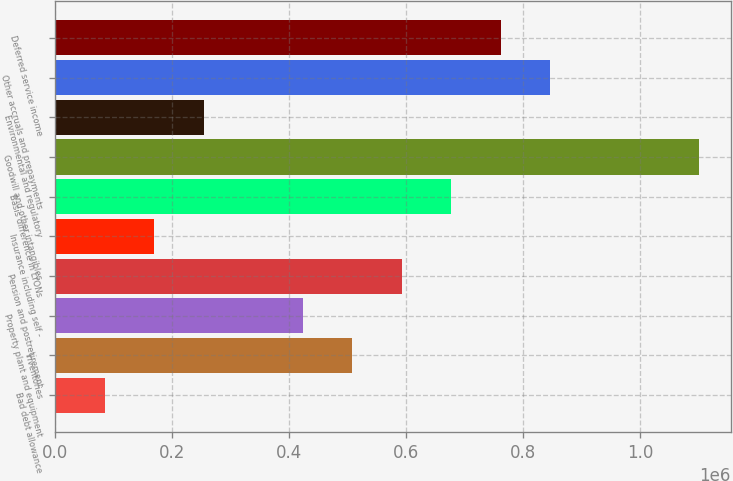<chart> <loc_0><loc_0><loc_500><loc_500><bar_chart><fcel>Bad debt allowance<fcel>Inventories<fcel>Property plant and equipment<fcel>Pension and postretirement<fcel>Insurance including self -<fcel>Basis difference in LYONs<fcel>Goodwill and other intangibles<fcel>Environmental and regulatory<fcel>Other accruals and prepayments<fcel>Deferred service income<nl><fcel>84846.1<fcel>507662<fcel>423098<fcel>592225<fcel>169409<fcel>676788<fcel>1.0996e+06<fcel>253972<fcel>845914<fcel>761351<nl></chart> 